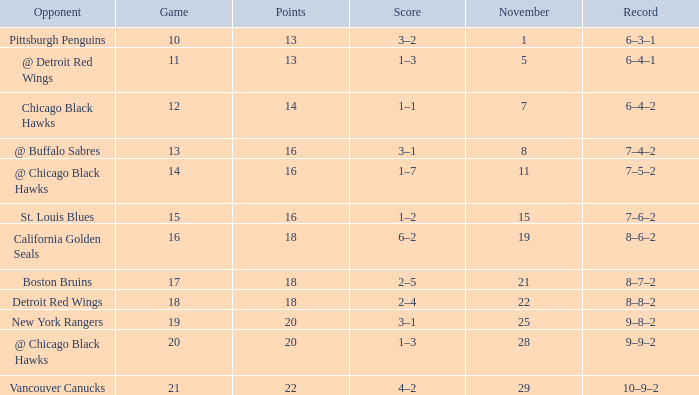What record has a november greater than 11, and st. louis blues as the opponent? 7–6–2. 